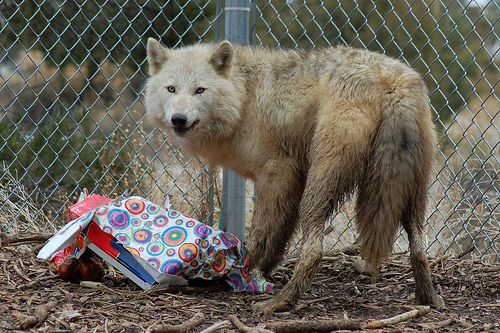<image>
Is the pole above the wrapping paper? Yes. The pole is positioned above the wrapping paper in the vertical space, higher up in the scene. 